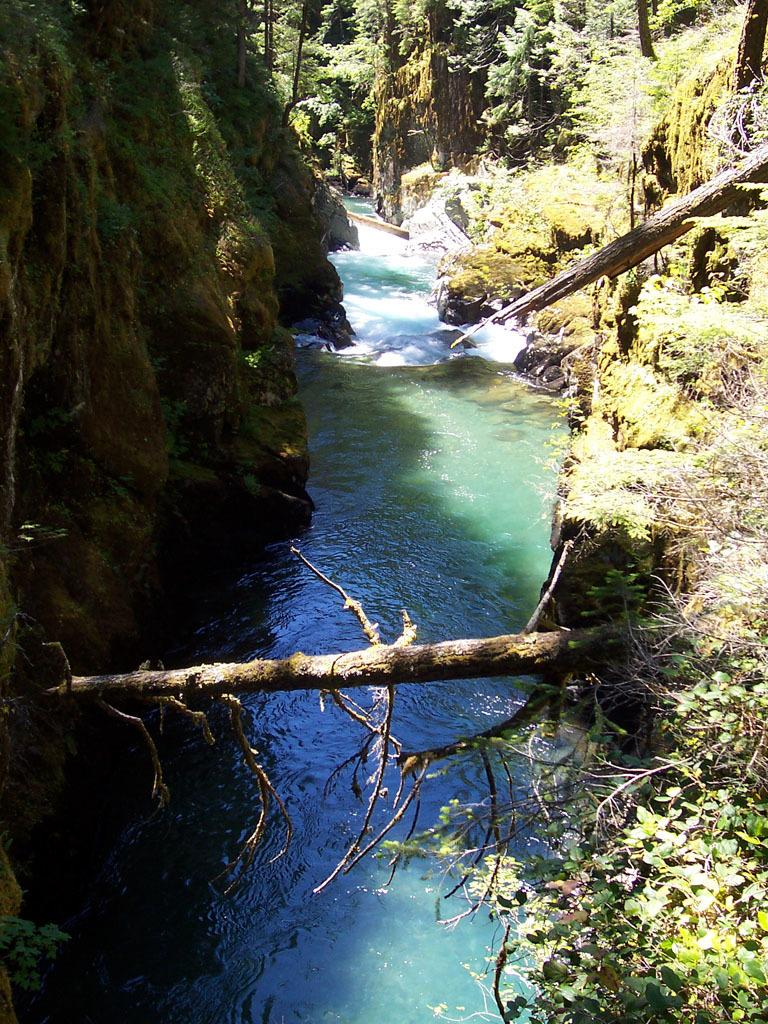What is the primary element visible in the image? There is water in the image. What else can be seen in the water? There are logs in the image. What type of vegetation is present in the image? Creepers and trees are present in the image. What type of landscape feature can be seen in the image? There are hills in the image. Is there any meat visible in the image? No, there is no meat present in the image. Does the existence of the image prove the existence of a parallel universe? The existence of the image does not prove the existence of a parallel universe; it is simply a photograph of a natural scene. 